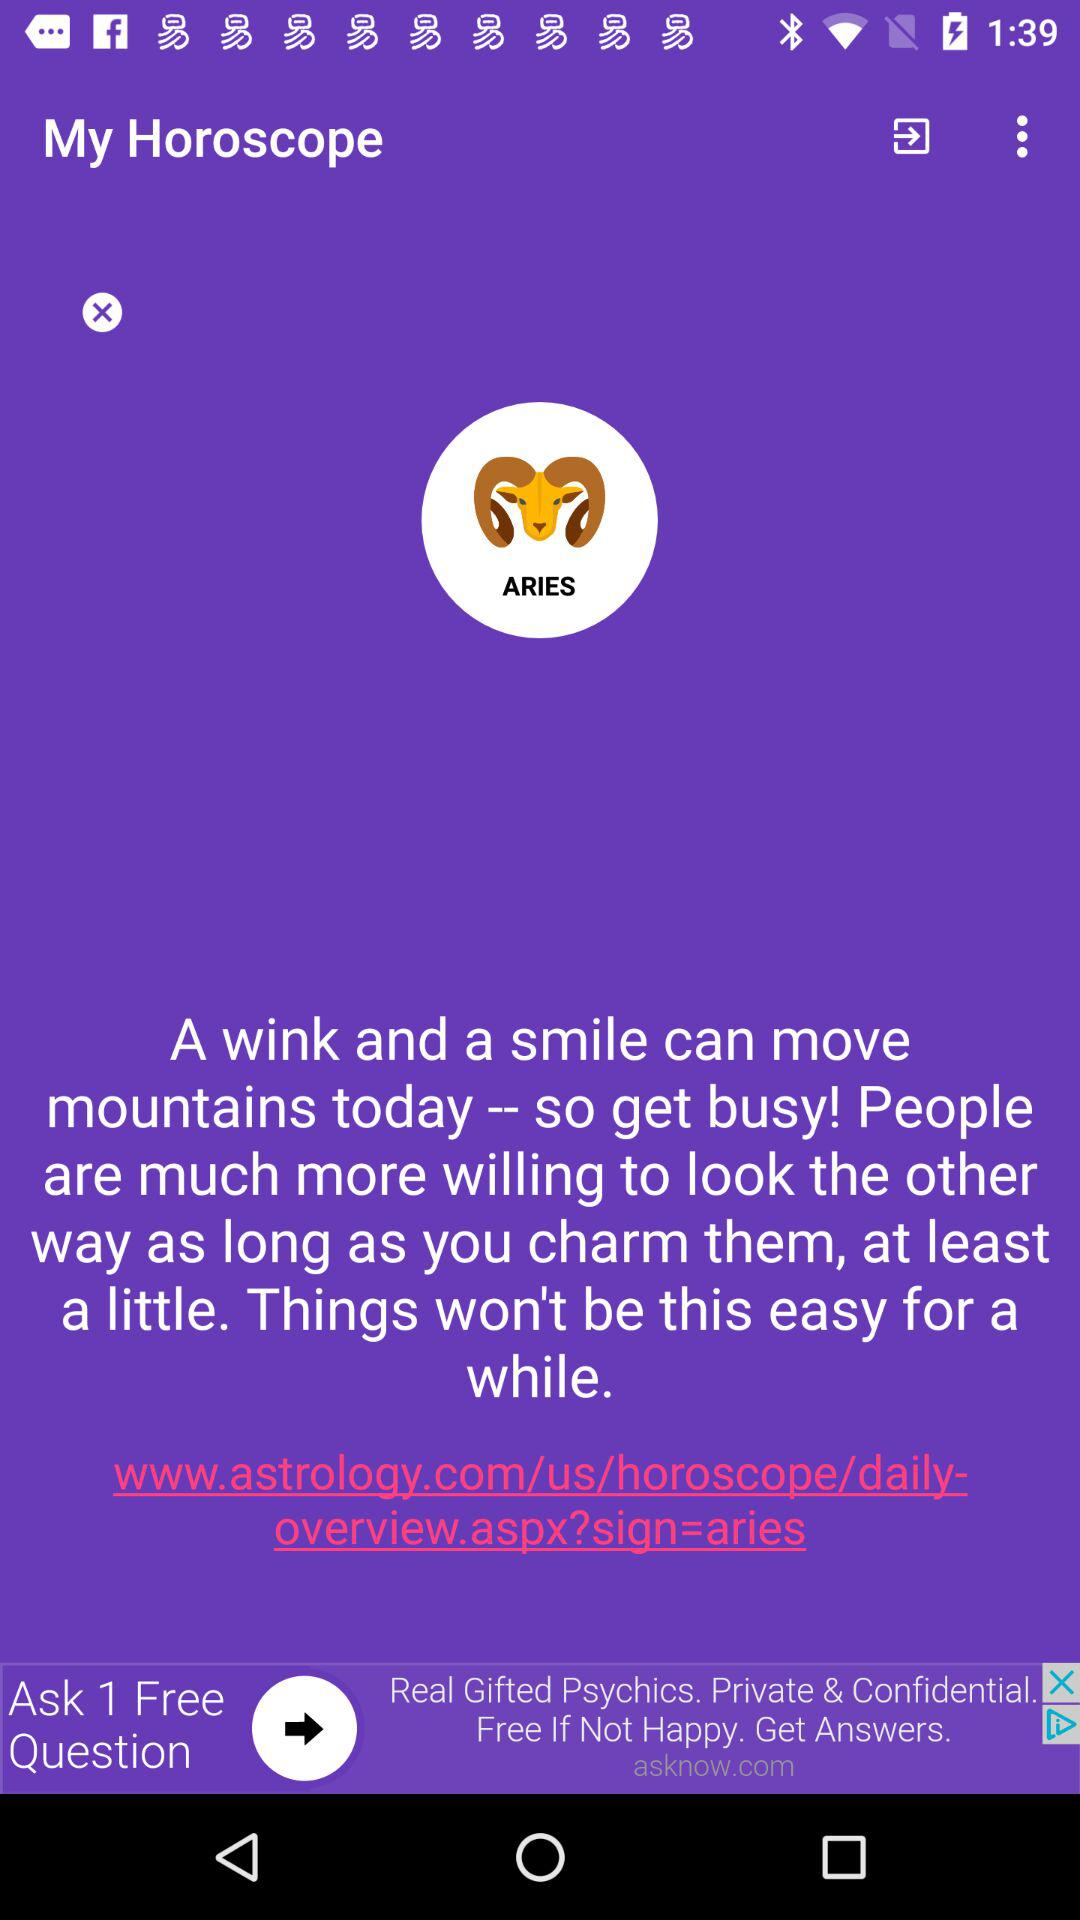What zodiac sign is shown? The shown zodiac sign is Aries. 